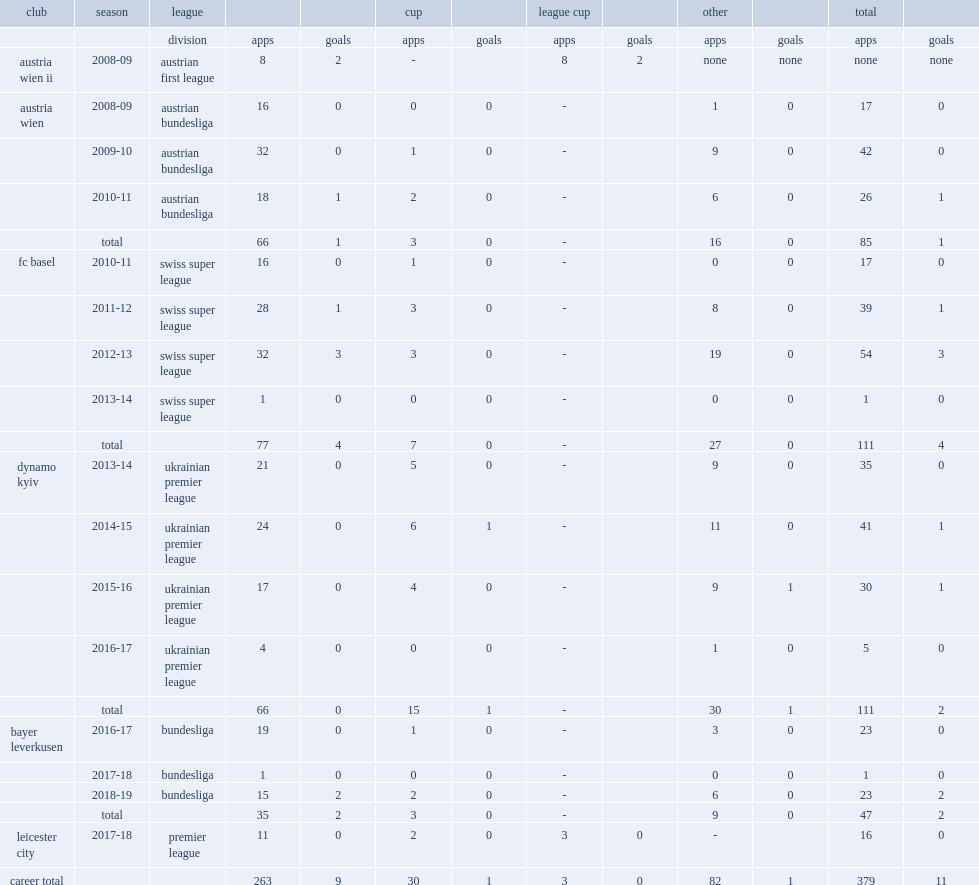In 2010-11 season, which league did dragovic play in club fc basel? Swiss super league. 